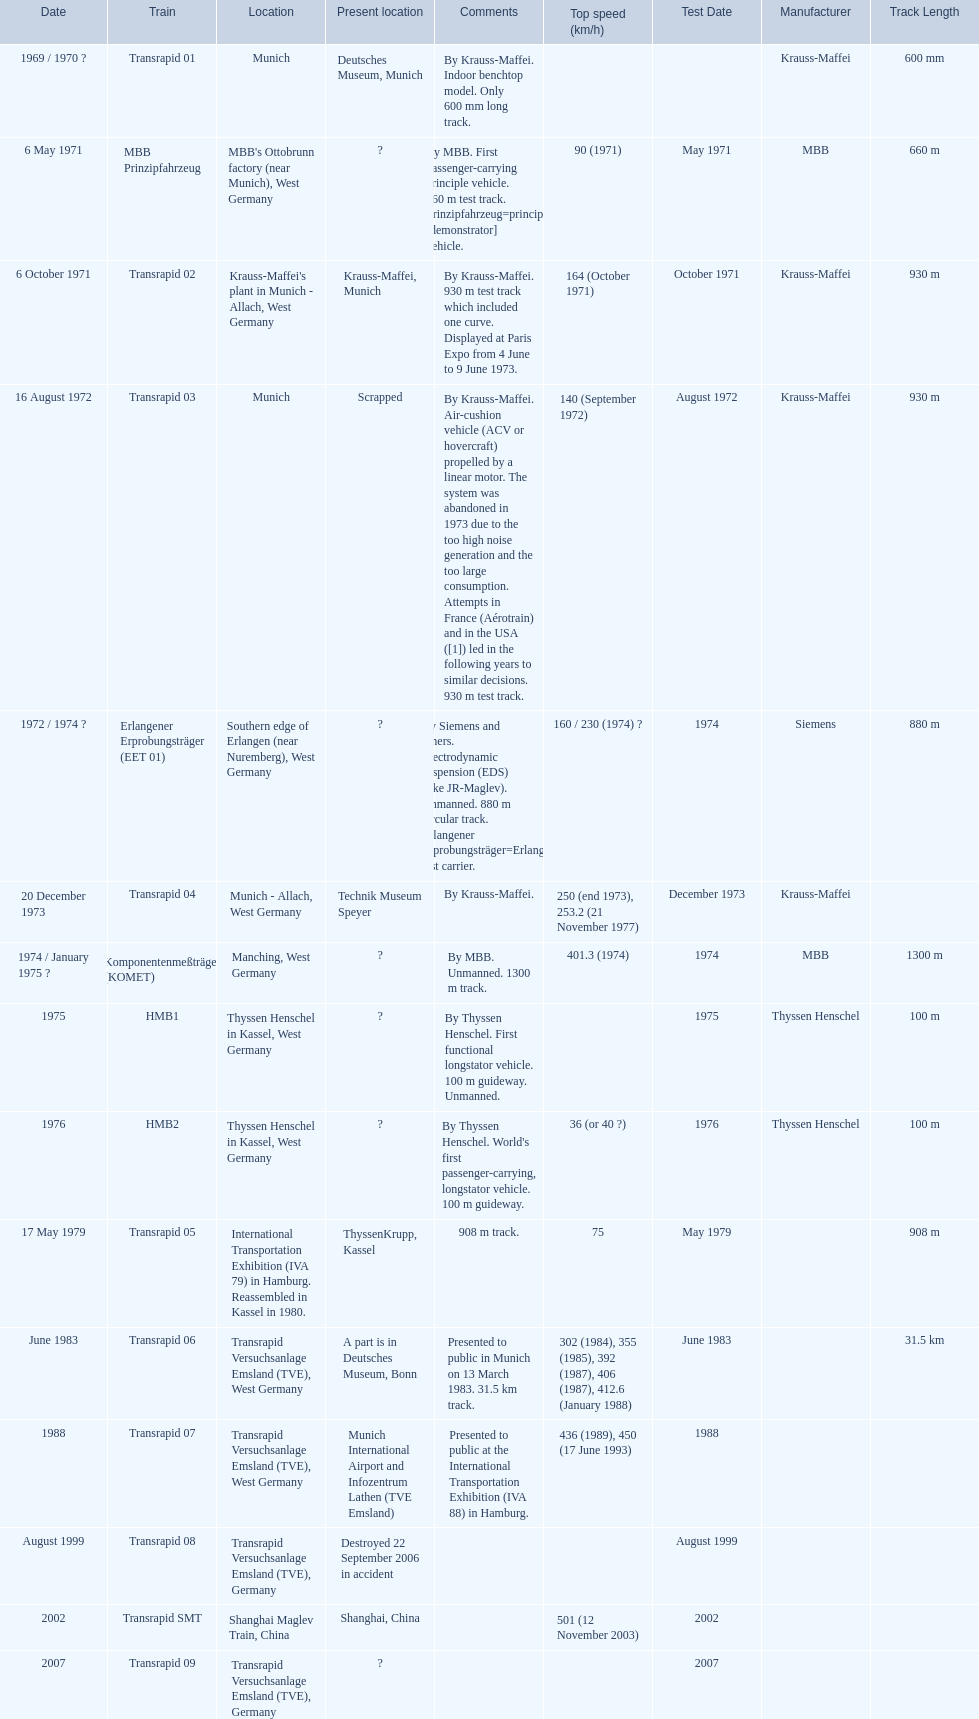Which trains had a top speed listed? MBB Prinzipfahrzeug, Transrapid 02, Transrapid 03, Erlangener Erprobungsträger (EET 01), Transrapid 04, Komponentenmeßträger (KOMET), HMB2, Transrapid 05, Transrapid 06, Transrapid 07, Transrapid SMT. Which ones list munich as a location? MBB Prinzipfahrzeug, Transrapid 02, Transrapid 03. Of these which ones present location is known? Transrapid 02, Transrapid 03. Which of those is no longer in operation? Transrapid 03. 